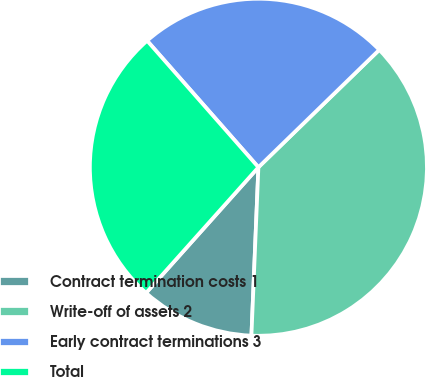Convert chart. <chart><loc_0><loc_0><loc_500><loc_500><pie_chart><fcel>Contract termination costs 1<fcel>Write-off of assets 2<fcel>Early contract terminations 3<fcel>Total<nl><fcel>10.95%<fcel>37.93%<fcel>24.21%<fcel>26.91%<nl></chart> 